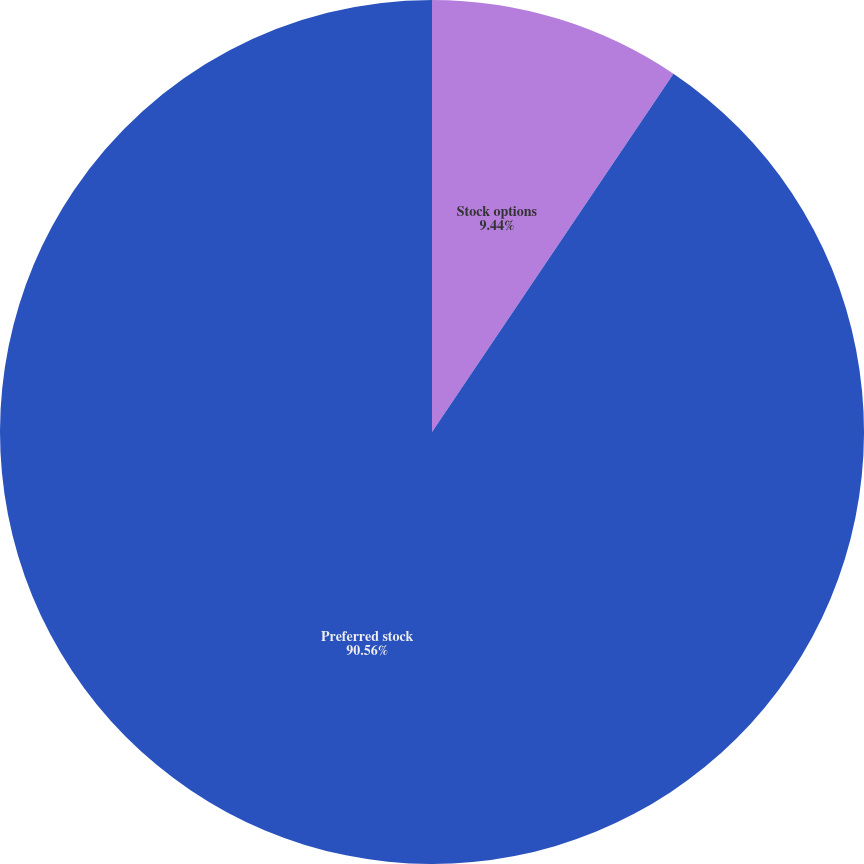Convert chart to OTSL. <chart><loc_0><loc_0><loc_500><loc_500><pie_chart><fcel>Stock options<fcel>Preferred stock<nl><fcel>9.44%<fcel>90.56%<nl></chart> 